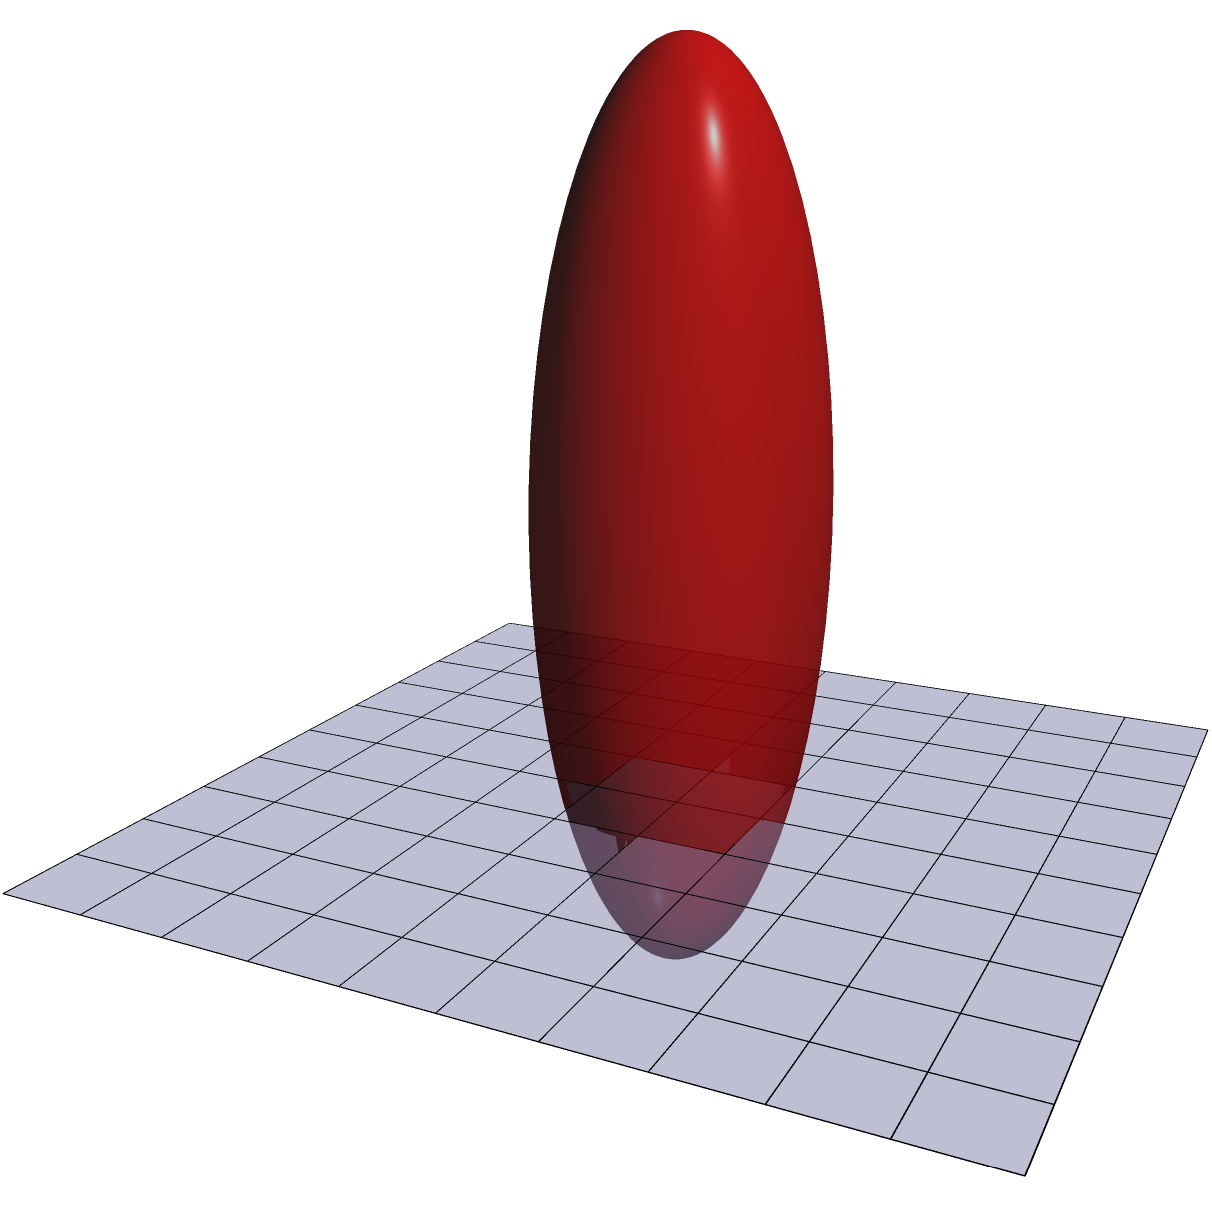In 3D medical imaging for tumor detection, which of the following machine learning approaches would be most effective for simultaneously segmenting both the organ and the tumor, considering the need for precise boundaries and the potential for overlapping regions?

A) U-Net
B) Mask R-CNN
C) nnU-Net
D) DeepLab v3+ To answer this question, let's consider the characteristics of each approach and how they relate to the task of segmenting organs and tumors in 3D medical imaging:

1. U-Net:
   - Designed for biomedical image segmentation
   - Efficient with small training datasets
   - Good at capturing fine details
   - Originally designed for 2D images

2. Mask R-CNN:
   - Instance segmentation model
   - Can differentiate between multiple instances of the same class
   - Better suited for natural images with multiple objects

3. nnU-Net:
   - Specifically designed for medical image segmentation
   - Automatically adapts to various 3D medical imaging tasks
   - Incorporates domain-specific optimizations
   - Performs well on a wide range of medical segmentation challenges

4. DeepLab v3+:
   - Designed for semantic segmentation in natural images
   - Uses atrous convolutions for multi-scale processing
   - Not specifically optimized for medical imaging

Considering the task of simultaneously segmenting both the organ and the tumor in 3D medical imaging:

1. We need a model that can handle 3D data effectively.
2. The model should be able to segment multiple classes (organ and tumor) simultaneously.
3. It should be optimized for medical imaging tasks, where precise boundaries are crucial.
4. The ability to handle potential overlapping regions between the organ and tumor is important.

Given these requirements, the nnU-Net (nested U-Net) architecture stands out as the most suitable approach. It is specifically designed for medical image segmentation tasks, can handle 3D data, and has shown state-of-the-art performance across various medical imaging challenges. Its ability to automatically adapt to different segmentation tasks makes it particularly well-suited for simultaneously segmenting organs and tumors, even in complex scenarios with overlapping regions.
Answer: C) nnU-Net 